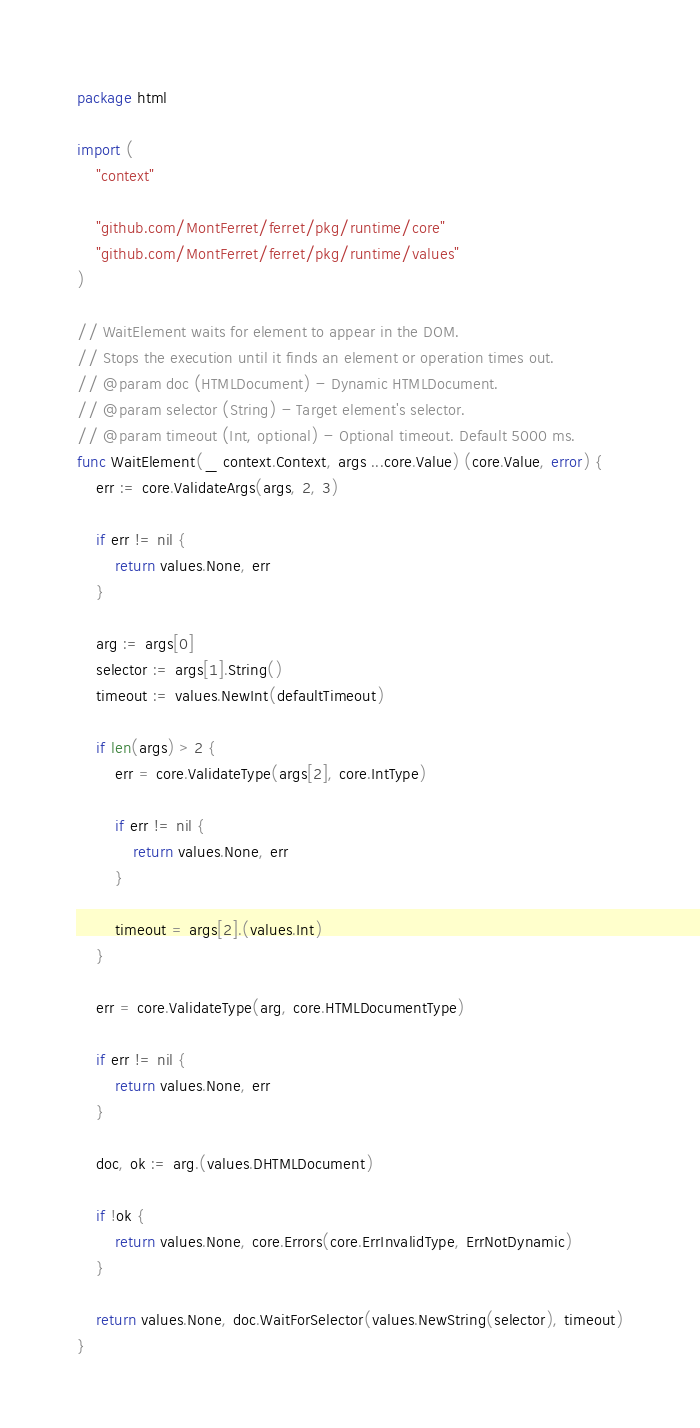<code> <loc_0><loc_0><loc_500><loc_500><_Go_>package html

import (
	"context"

	"github.com/MontFerret/ferret/pkg/runtime/core"
	"github.com/MontFerret/ferret/pkg/runtime/values"
)

// WaitElement waits for element to appear in the DOM.
// Stops the execution until it finds an element or operation times out.
// @param doc (HTMLDocument) - Dynamic HTMLDocument.
// @param selector (String) - Target element's selector.
// @param timeout (Int, optional) - Optional timeout. Default 5000 ms.
func WaitElement(_ context.Context, args ...core.Value) (core.Value, error) {
	err := core.ValidateArgs(args, 2, 3)

	if err != nil {
		return values.None, err
	}

	arg := args[0]
	selector := args[1].String()
	timeout := values.NewInt(defaultTimeout)

	if len(args) > 2 {
		err = core.ValidateType(args[2], core.IntType)

		if err != nil {
			return values.None, err
		}

		timeout = args[2].(values.Int)
	}

	err = core.ValidateType(arg, core.HTMLDocumentType)

	if err != nil {
		return values.None, err
	}

	doc, ok := arg.(values.DHTMLDocument)

	if !ok {
		return values.None, core.Errors(core.ErrInvalidType, ErrNotDynamic)
	}

	return values.None, doc.WaitForSelector(values.NewString(selector), timeout)
}
</code> 